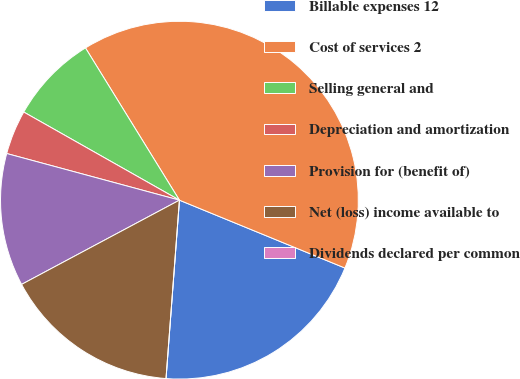Convert chart to OTSL. <chart><loc_0><loc_0><loc_500><loc_500><pie_chart><fcel>Billable expenses 12<fcel>Cost of services 2<fcel>Selling general and<fcel>Depreciation and amortization<fcel>Provision for (benefit of)<fcel>Net (loss) income available to<fcel>Dividends declared per common<nl><fcel>20.0%<fcel>39.99%<fcel>8.0%<fcel>4.0%<fcel>12.0%<fcel>16.0%<fcel>0.0%<nl></chart> 